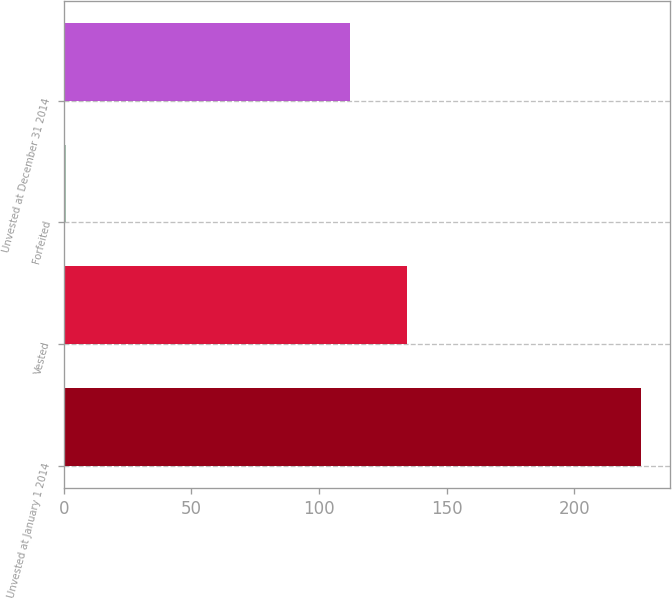<chart> <loc_0><loc_0><loc_500><loc_500><bar_chart><fcel>Unvested at January 1 2014<fcel>Vested<fcel>Forfeited<fcel>Unvested at December 31 2014<nl><fcel>226<fcel>134.5<fcel>1<fcel>112<nl></chart> 